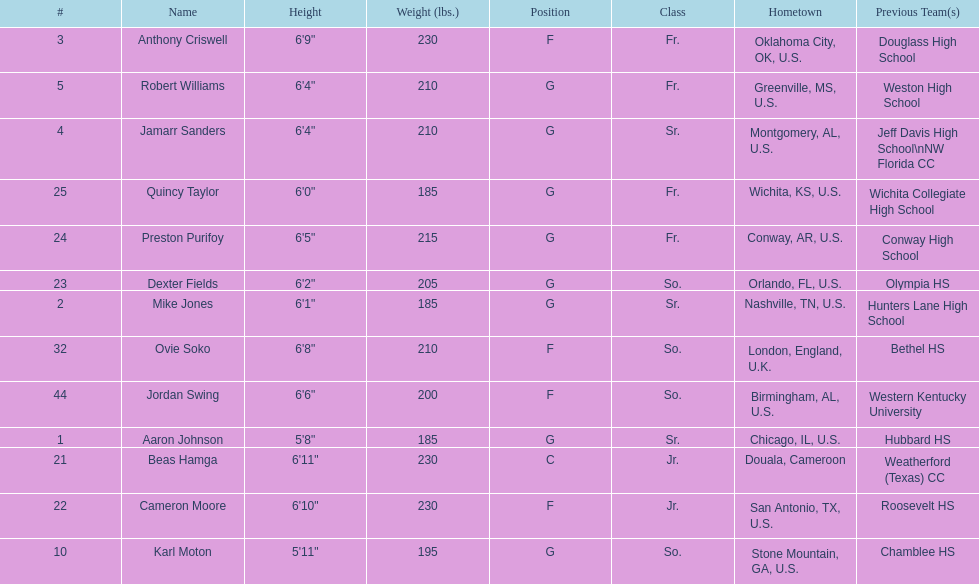Tell me the number of juniors on the team. 2. 